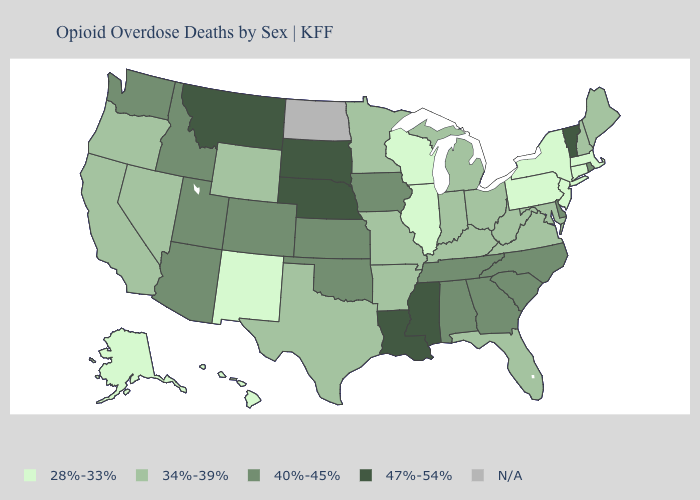What is the value of Utah?
Answer briefly. 40%-45%. What is the lowest value in states that border Utah?
Concise answer only. 28%-33%. Name the states that have a value in the range 34%-39%?
Give a very brief answer. Arkansas, California, Florida, Indiana, Kentucky, Maine, Maryland, Michigan, Minnesota, Missouri, Nevada, New Hampshire, Ohio, Oregon, Texas, Virginia, West Virginia, Wyoming. Name the states that have a value in the range 28%-33%?
Be succinct. Alaska, Connecticut, Hawaii, Illinois, Massachusetts, New Jersey, New Mexico, New York, Pennsylvania, Wisconsin. Name the states that have a value in the range 34%-39%?
Write a very short answer. Arkansas, California, Florida, Indiana, Kentucky, Maine, Maryland, Michigan, Minnesota, Missouri, Nevada, New Hampshire, Ohio, Oregon, Texas, Virginia, West Virginia, Wyoming. Name the states that have a value in the range 40%-45%?
Quick response, please. Alabama, Arizona, Colorado, Delaware, Georgia, Idaho, Iowa, Kansas, North Carolina, Oklahoma, Rhode Island, South Carolina, Tennessee, Utah, Washington. Name the states that have a value in the range 28%-33%?
Concise answer only. Alaska, Connecticut, Hawaii, Illinois, Massachusetts, New Jersey, New Mexico, New York, Pennsylvania, Wisconsin. Among the states that border Connecticut , which have the highest value?
Keep it brief. Rhode Island. Which states hav the highest value in the MidWest?
Give a very brief answer. Nebraska, South Dakota. What is the value of Florida?
Be succinct. 34%-39%. Name the states that have a value in the range 47%-54%?
Answer briefly. Louisiana, Mississippi, Montana, Nebraska, South Dakota, Vermont. What is the value of Massachusetts?
Be succinct. 28%-33%. Among the states that border New Jersey , which have the lowest value?
Quick response, please. New York, Pennsylvania. 